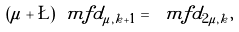<formula> <loc_0><loc_0><loc_500><loc_500>( \mu + \L ) \ m f { d } _ { \mu , k + 1 } = \ m f { d } _ { 2 \mu , k } ,</formula> 